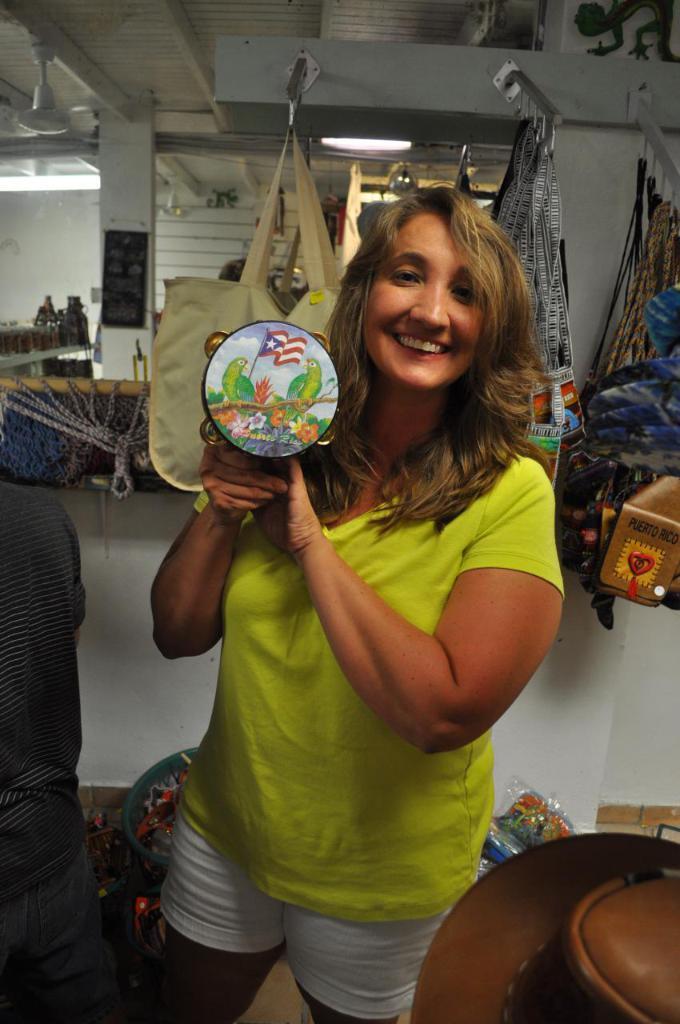Could you give a brief overview of what you see in this image? In this image there is a woman standing on the floor. She is holding an object in her hand. Behind her there are few bags hanged to the metal rods. Left side a person is standing. Right bottom there is an object. Behind there are few objects on the floor. Left side there is a pillar. A fan and a light are attached to the roof. 